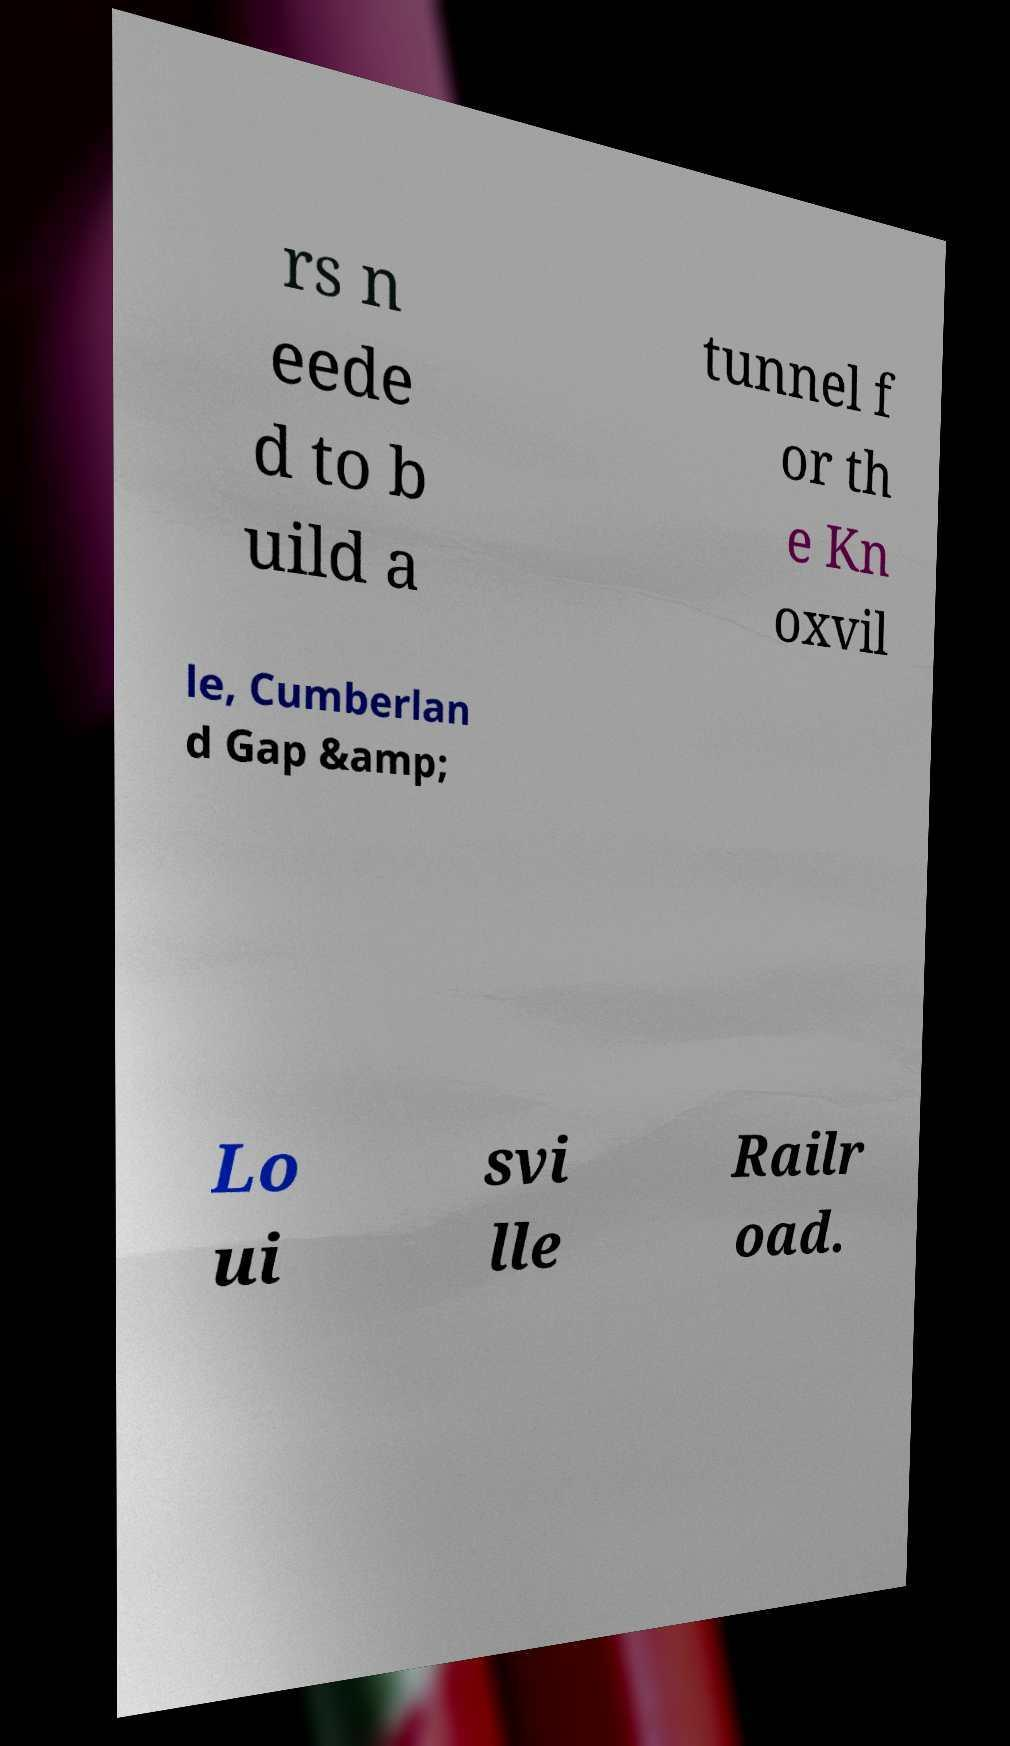There's text embedded in this image that I need extracted. Can you transcribe it verbatim? rs n eede d to b uild a tunnel f or th e Kn oxvil le, Cumberlan d Gap &amp; Lo ui svi lle Railr oad. 